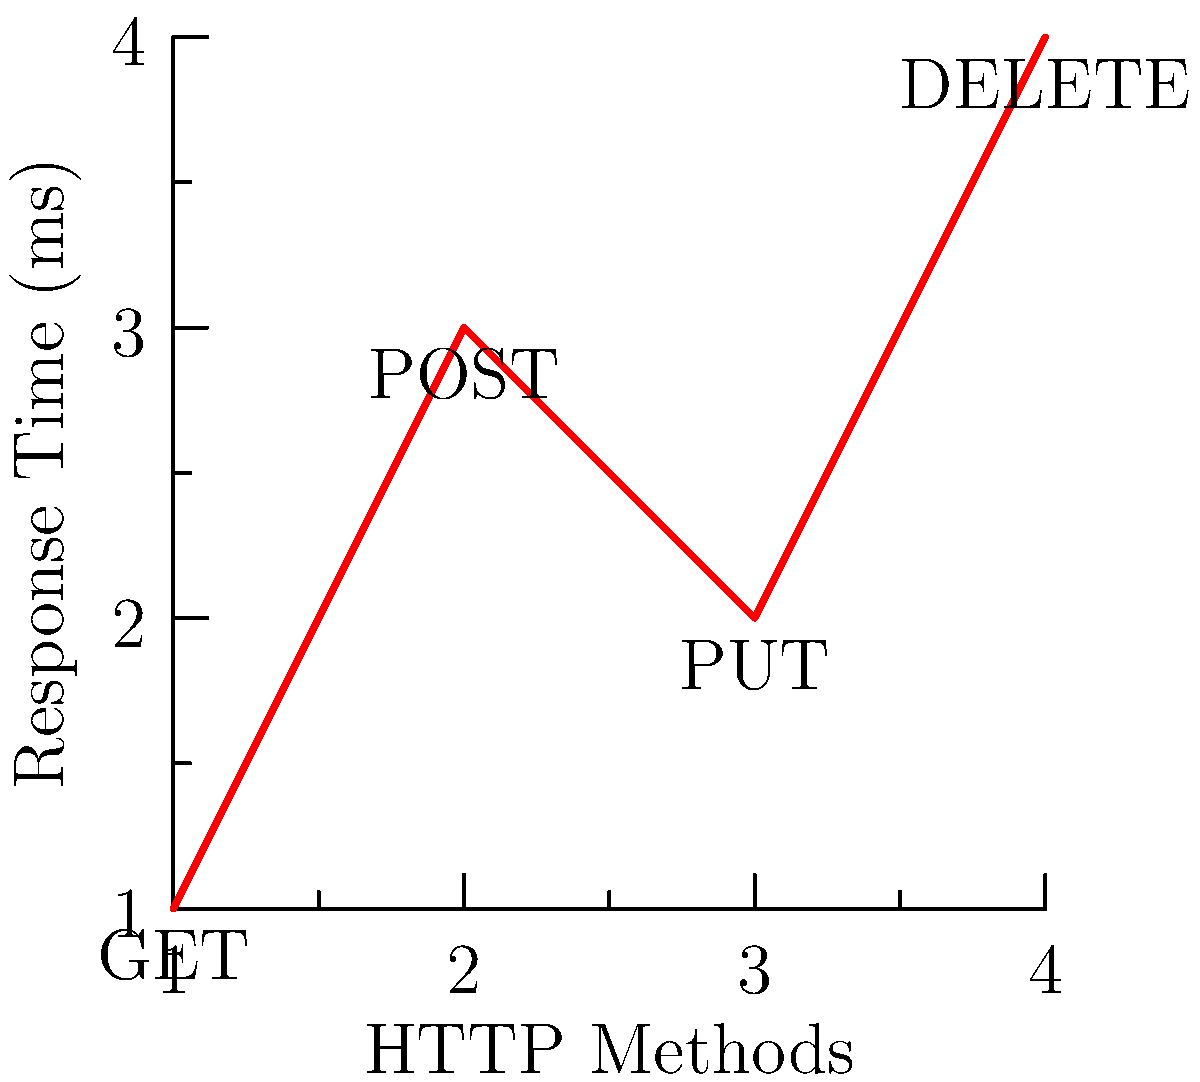Based on the graph showing the average response times for different HTTP methods in a basic HTTP server implementation, which method appears to have the lowest average response time and would be most efficient for retrieving data? To determine the most efficient HTTP method for retrieving data, we need to analyze the graph:

1. The x-axis represents different HTTP methods: GET, POST, PUT, and DELETE.
2. The y-axis represents the response time in milliseconds.
3. We need to find the method with the lowest point on the graph, indicating the shortest response time.

Analyzing each method:
- GET: (1, 1) - 1 ms
- POST: (2, 3) - 3 ms
- PUT: (3, 2) - 2 ms
- DELETE: (4, 4) - 4 ms

The GET method has the lowest point on the graph at (1, 1), corresponding to a 1 ms response time. This makes it the most efficient method for retrieving data.

In practice, GET is indeed the standard method for retrieving data in HTTP, as it is designed to be fast and cacheable. POST, PUT, and DELETE are typically used for creating, updating, and deleting resources, respectively, which often involve more server-side processing and thus longer response times.
Answer: GET 